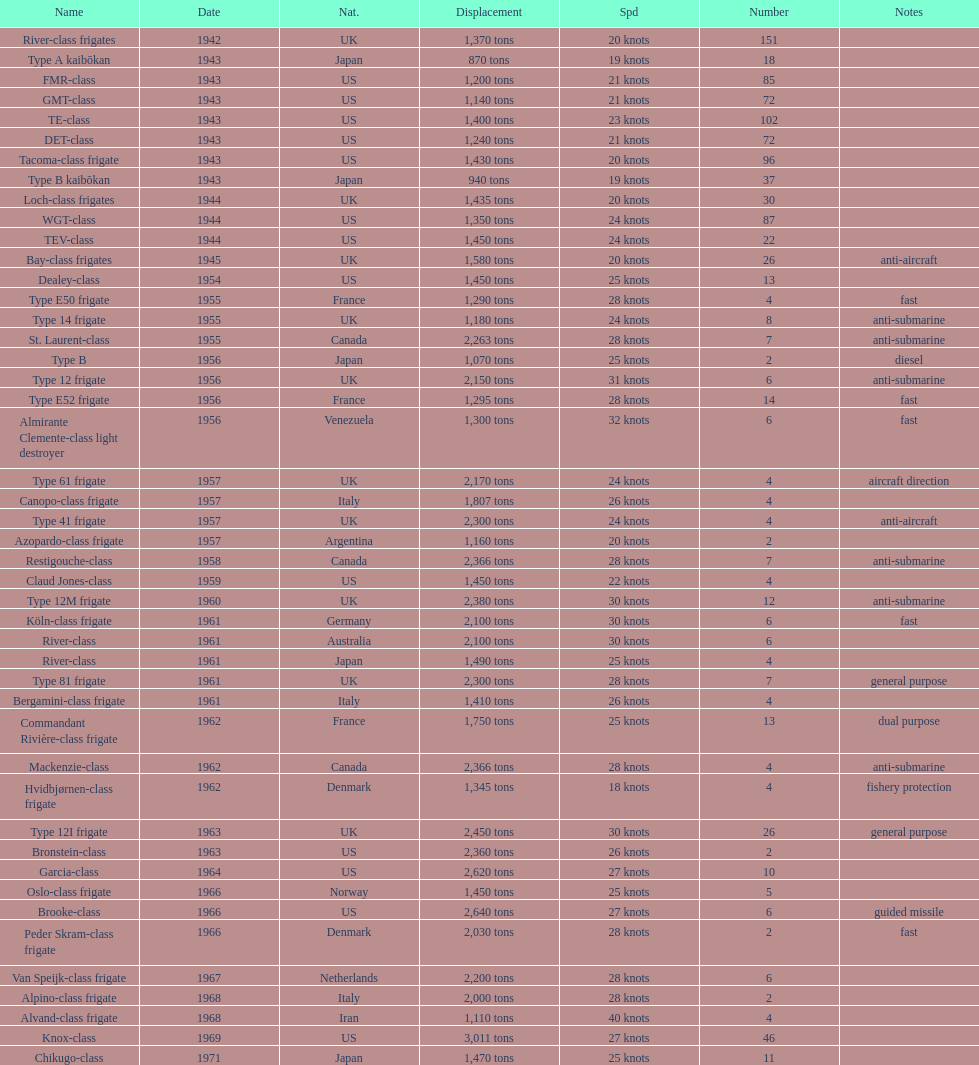In 1968 italy used alpino-class frigate. what was its top speed? 28 knots. 